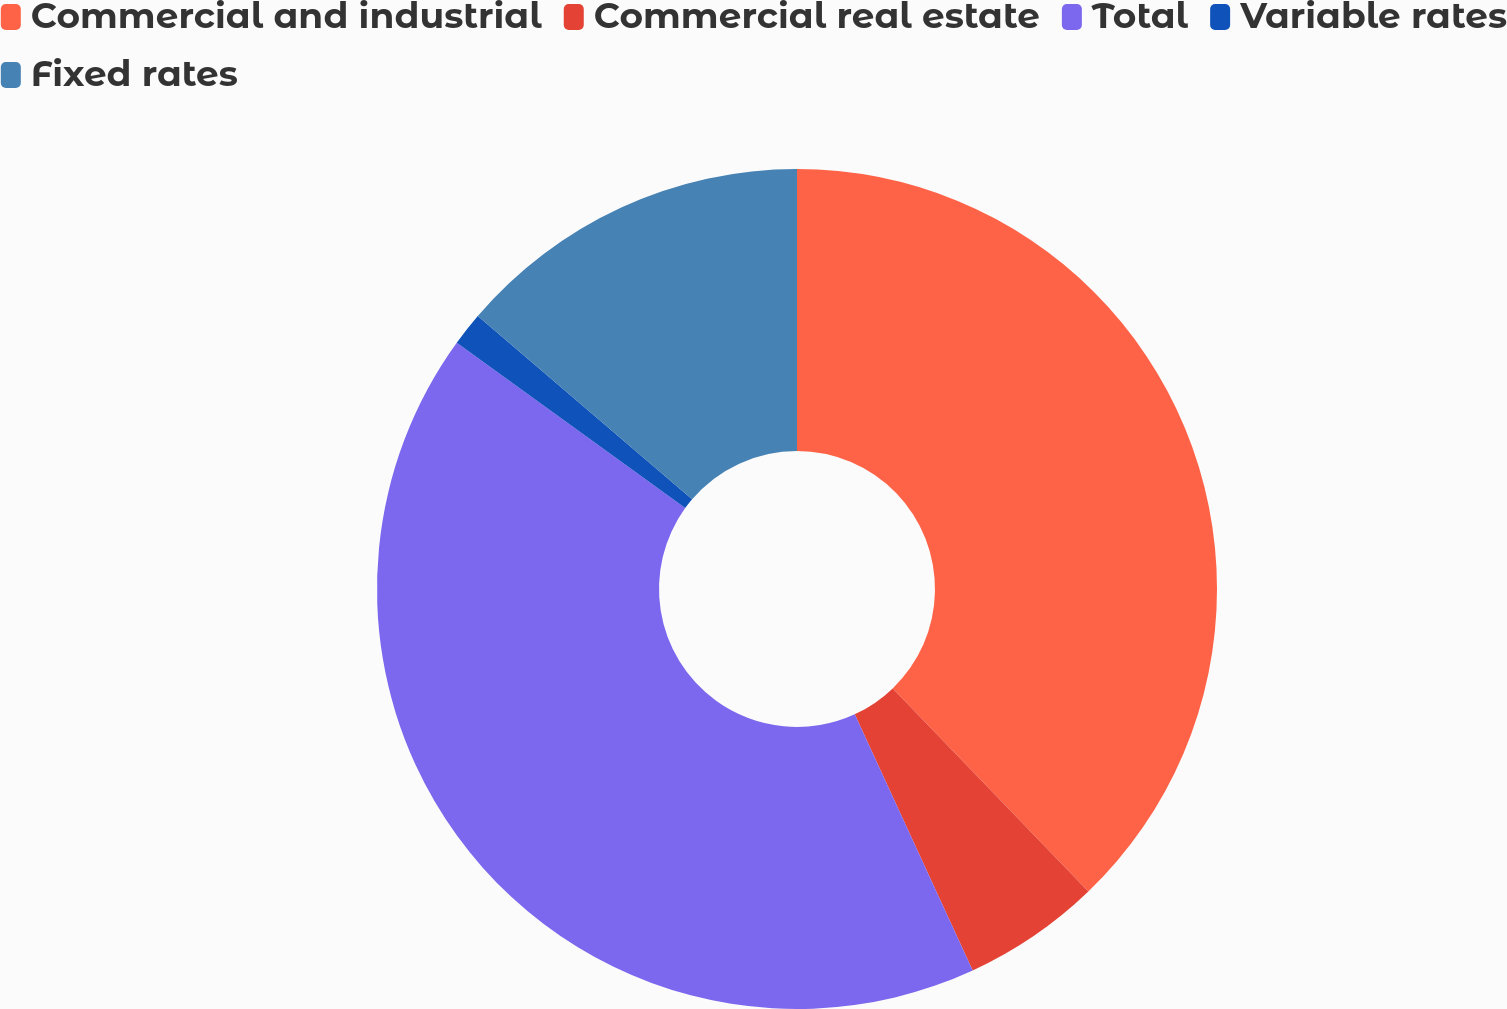Convert chart to OTSL. <chart><loc_0><loc_0><loc_500><loc_500><pie_chart><fcel>Commercial and industrial<fcel>Commercial real estate<fcel>Total<fcel>Variable rates<fcel>Fixed rates<nl><fcel>37.8%<fcel>5.33%<fcel>41.84%<fcel>1.29%<fcel>13.74%<nl></chart> 